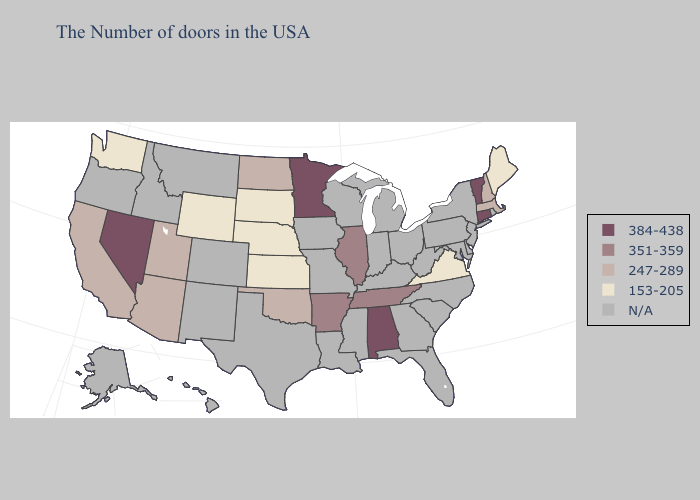What is the highest value in the West ?
Short answer required. 384-438. What is the lowest value in the South?
Give a very brief answer. 153-205. Does Arizona have the lowest value in the USA?
Be succinct. No. Name the states that have a value in the range 384-438?
Quick response, please. Vermont, Connecticut, Alabama, Minnesota, Nevada. Name the states that have a value in the range N/A?
Write a very short answer. Rhode Island, New York, New Jersey, Delaware, Maryland, Pennsylvania, North Carolina, South Carolina, West Virginia, Ohio, Florida, Georgia, Michigan, Kentucky, Indiana, Wisconsin, Mississippi, Louisiana, Missouri, Iowa, Texas, Colorado, New Mexico, Montana, Idaho, Oregon, Alaska, Hawaii. What is the value of Louisiana?
Keep it brief. N/A. Does Tennessee have the highest value in the South?
Write a very short answer. No. What is the value of New York?
Write a very short answer. N/A. What is the highest value in states that border Connecticut?
Quick response, please. 247-289. What is the highest value in the South ?
Keep it brief. 384-438. 